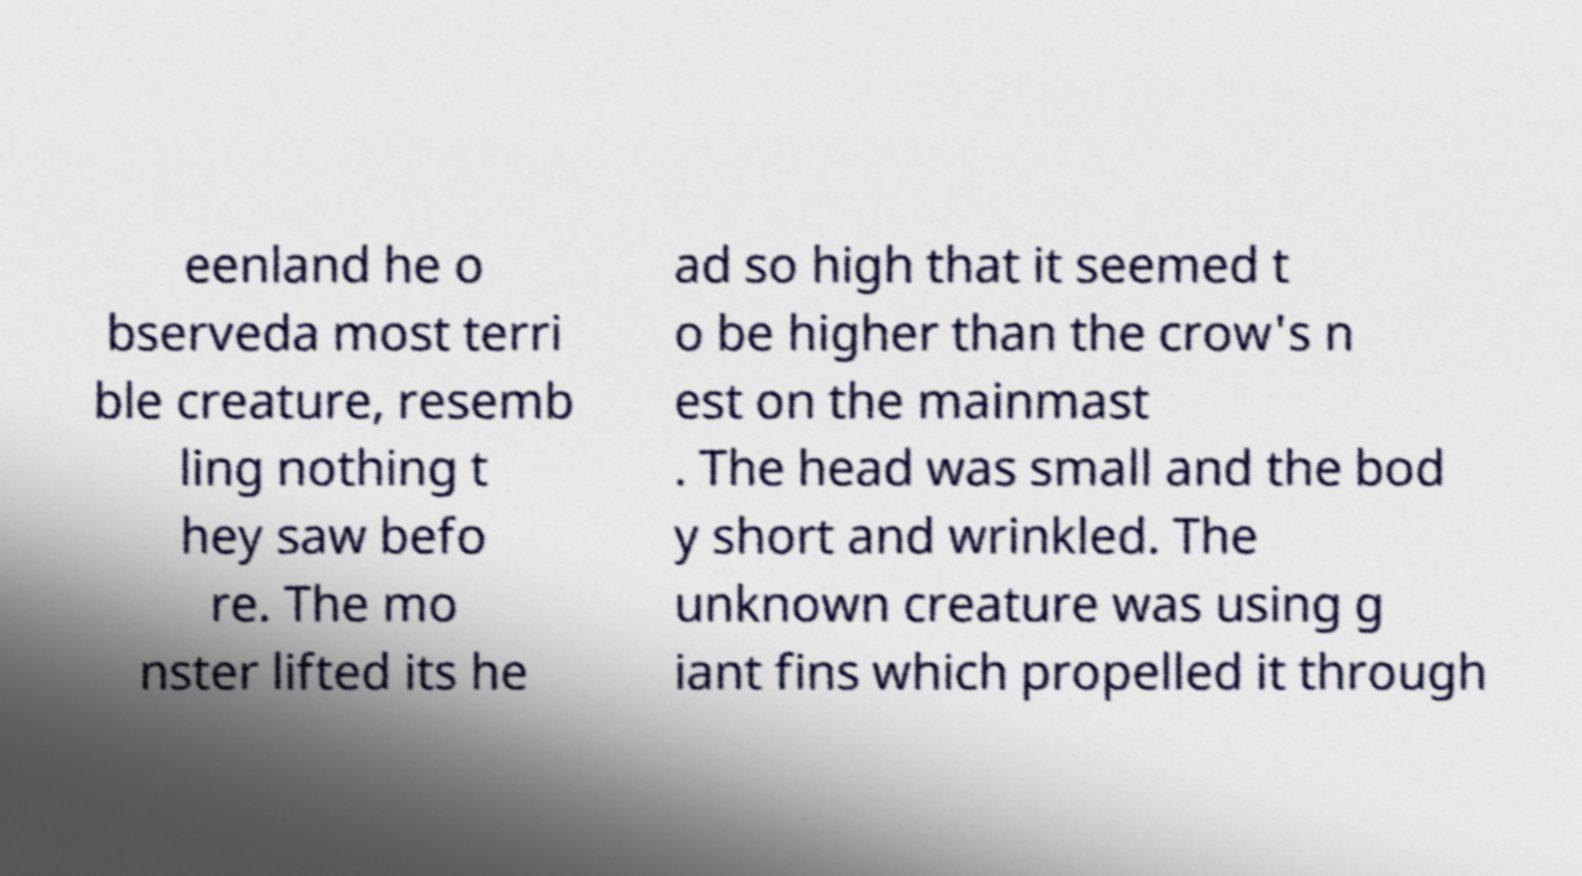What messages or text are displayed in this image? I need them in a readable, typed format. eenland he o bserveda most terri ble creature, resemb ling nothing t hey saw befo re. The mo nster lifted its he ad so high that it seemed t o be higher than the crow's n est on the mainmast . The head was small and the bod y short and wrinkled. The unknown creature was using g iant fins which propelled it through 